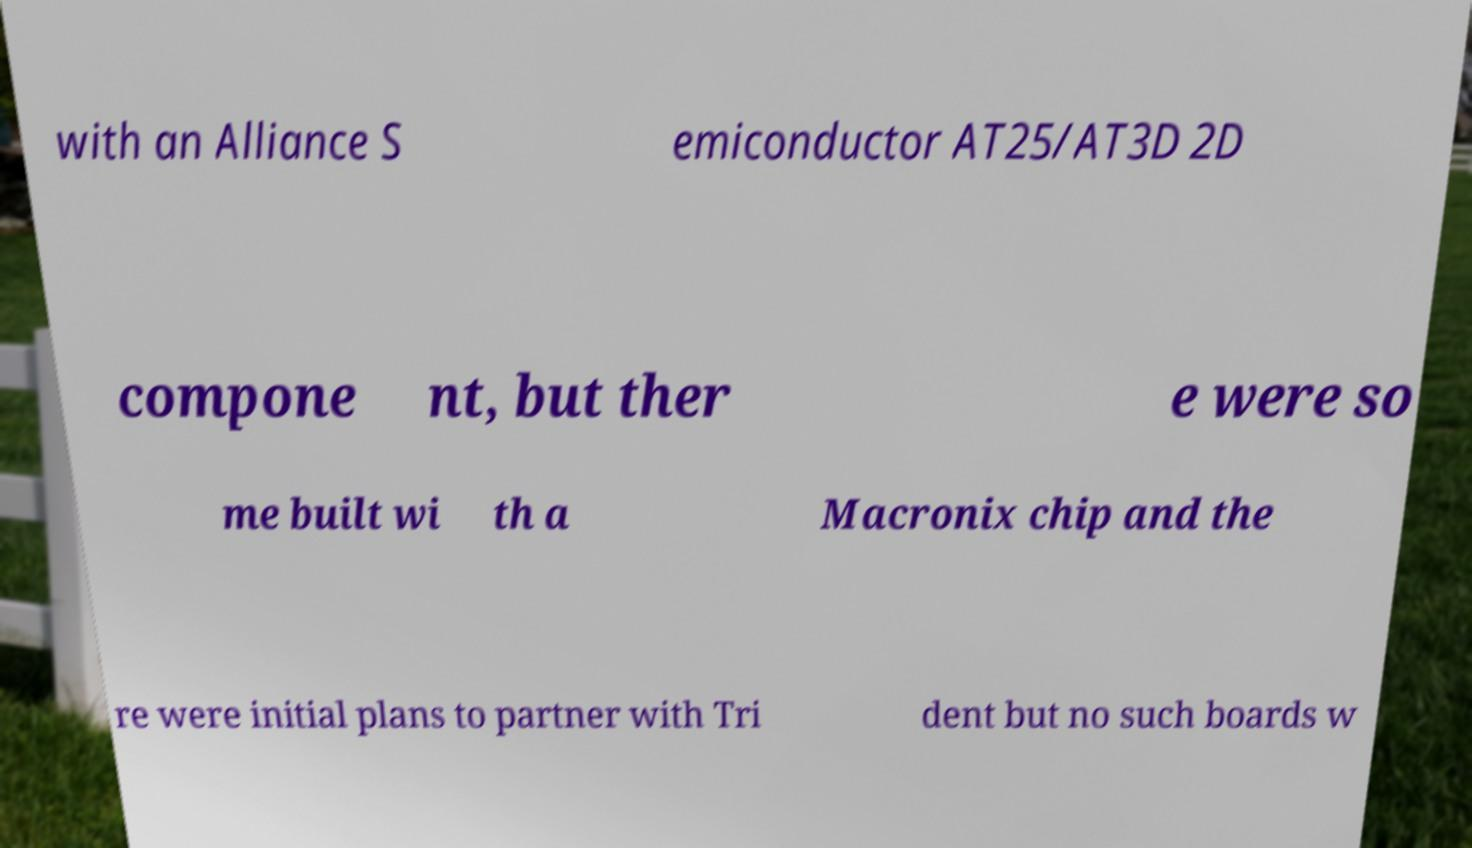There's text embedded in this image that I need extracted. Can you transcribe it verbatim? with an Alliance S emiconductor AT25/AT3D 2D compone nt, but ther e were so me built wi th a Macronix chip and the re were initial plans to partner with Tri dent but no such boards w 